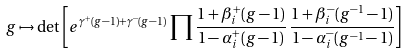<formula> <loc_0><loc_0><loc_500><loc_500>g \mapsto \det \left [ e ^ { \gamma ^ { + } ( g - 1 ) + \gamma ^ { - } ( g - 1 ) } \, \prod \frac { 1 + \beta ^ { + } _ { i } ( g - 1 ) } { 1 - \alpha ^ { + } _ { i } ( g - 1 ) } \, \frac { 1 + \beta ^ { - } _ { i } ( g ^ { - 1 } - 1 ) } { 1 - \alpha ^ { - } _ { i } ( g ^ { - 1 } - 1 ) } \right ]</formula> 